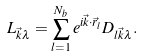Convert formula to latex. <formula><loc_0><loc_0><loc_500><loc_500>L _ { \vec { k } \lambda } = \sum _ { l = 1 } ^ { N _ { b } } e ^ { i \vec { k } \cdot \vec { r } _ { l } } D _ { l \vec { k } \lambda } .</formula> 